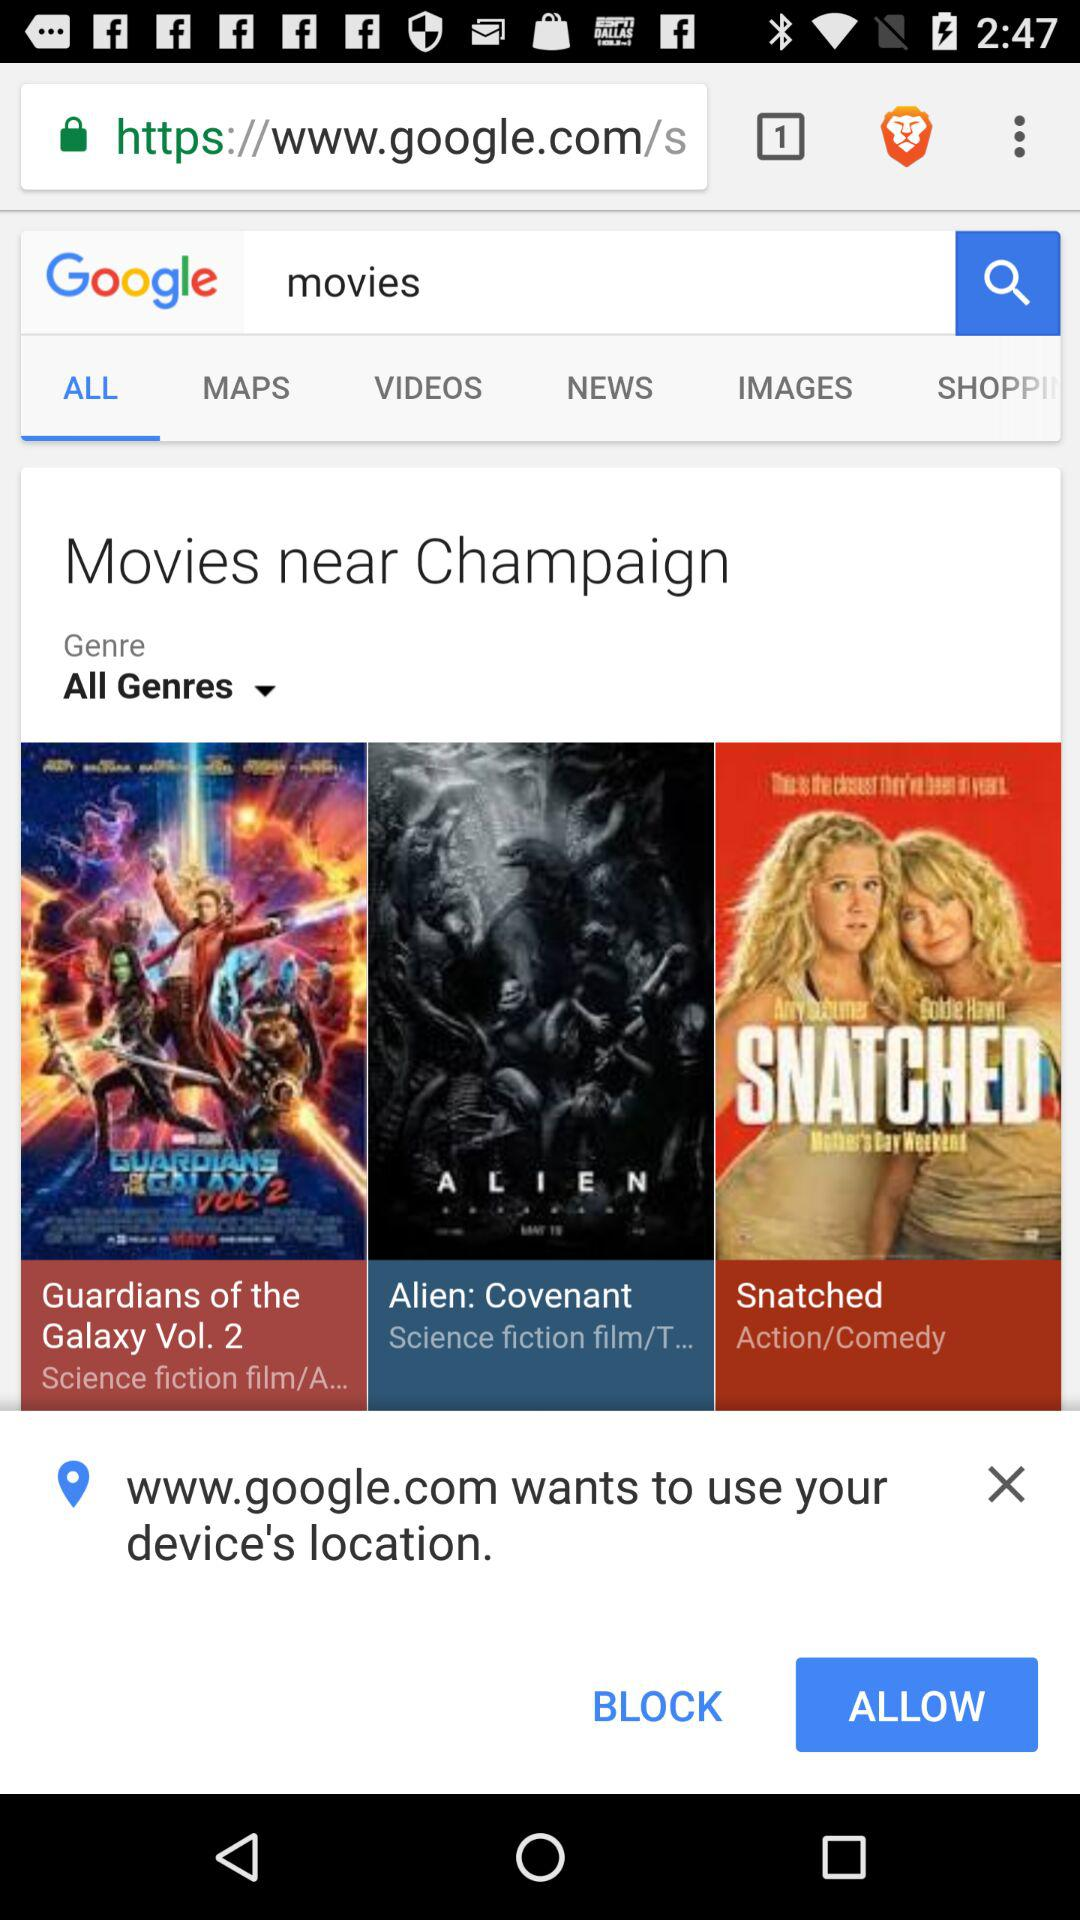What is the genre of the movie "Snatched"? The genres of the movie are action and comedy. 